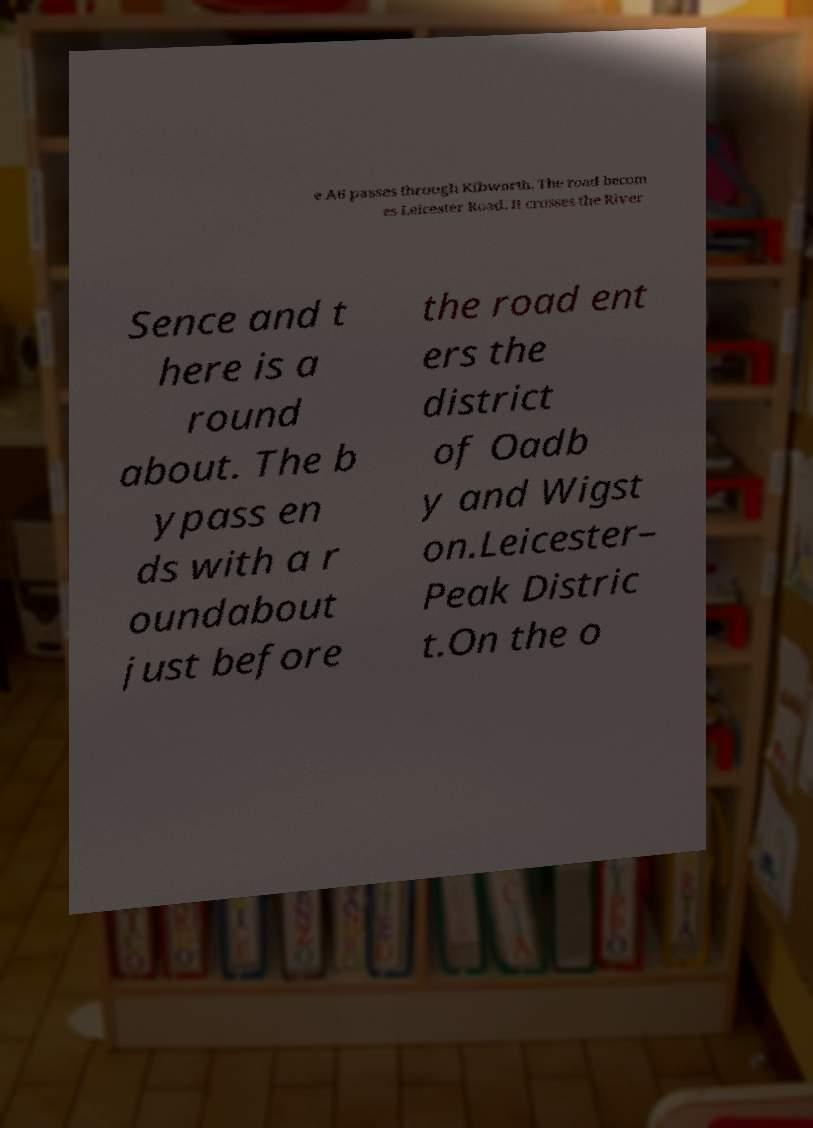Please identify and transcribe the text found in this image. e A6 passes through Kibworth. The road becom es Leicester Road. It crosses the River Sence and t here is a round about. The b ypass en ds with a r oundabout just before the road ent ers the district of Oadb y and Wigst on.Leicester– Peak Distric t.On the o 